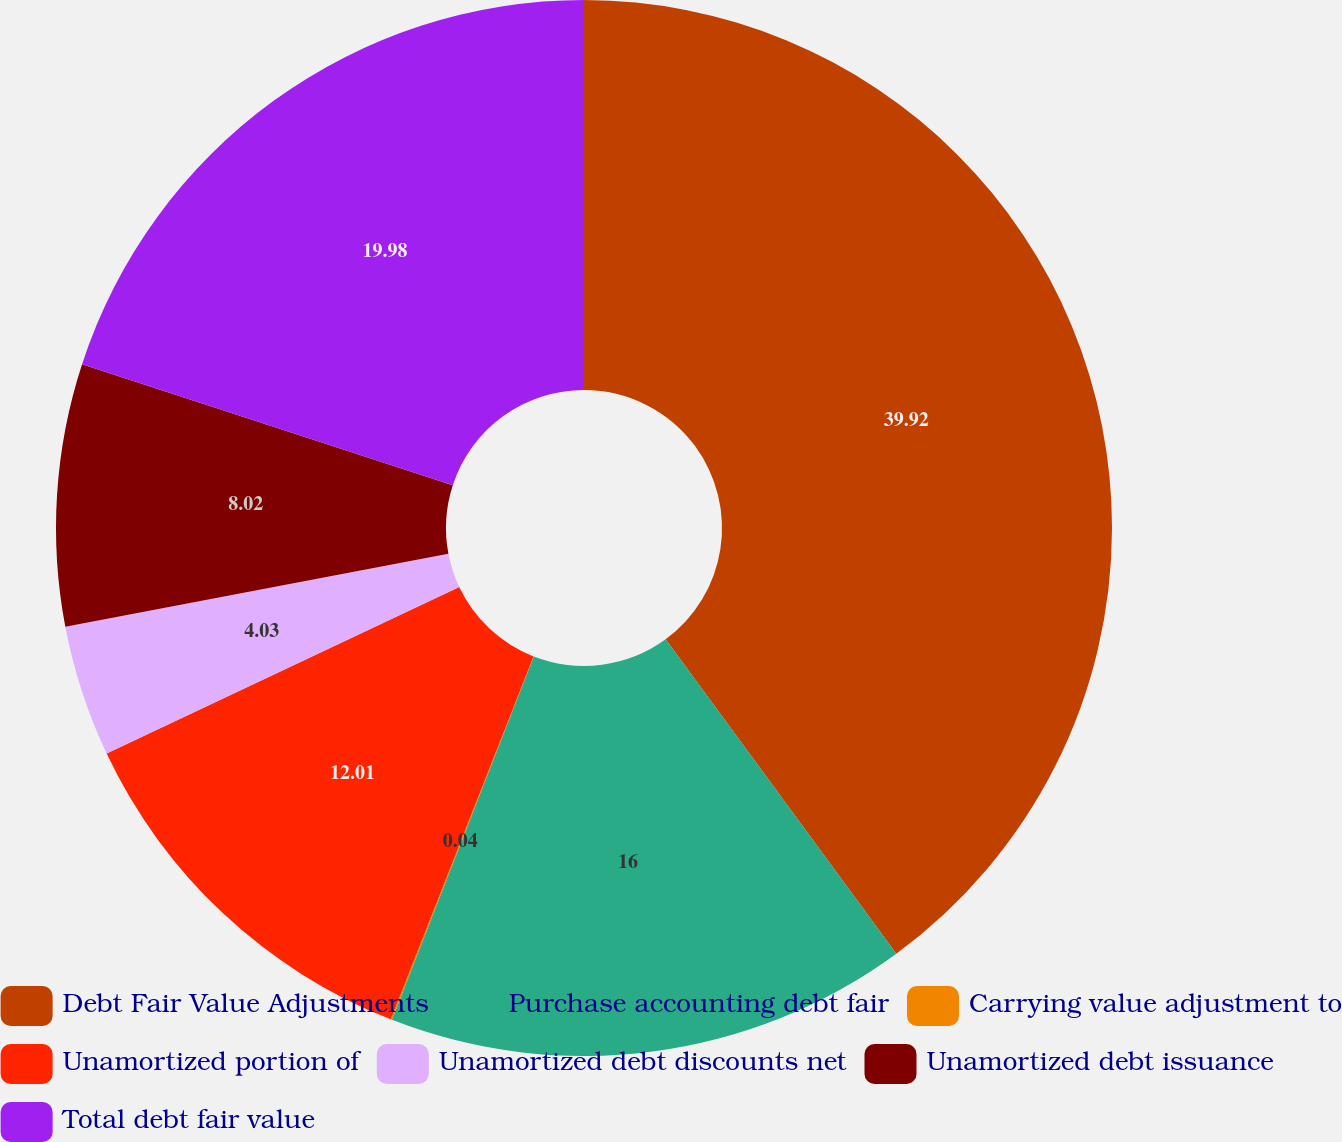Convert chart. <chart><loc_0><loc_0><loc_500><loc_500><pie_chart><fcel>Debt Fair Value Adjustments<fcel>Purchase accounting debt fair<fcel>Carrying value adjustment to<fcel>Unamortized portion of<fcel>Unamortized debt discounts net<fcel>Unamortized debt issuance<fcel>Total debt fair value<nl><fcel>39.93%<fcel>16.0%<fcel>0.04%<fcel>12.01%<fcel>4.03%<fcel>8.02%<fcel>19.98%<nl></chart> 